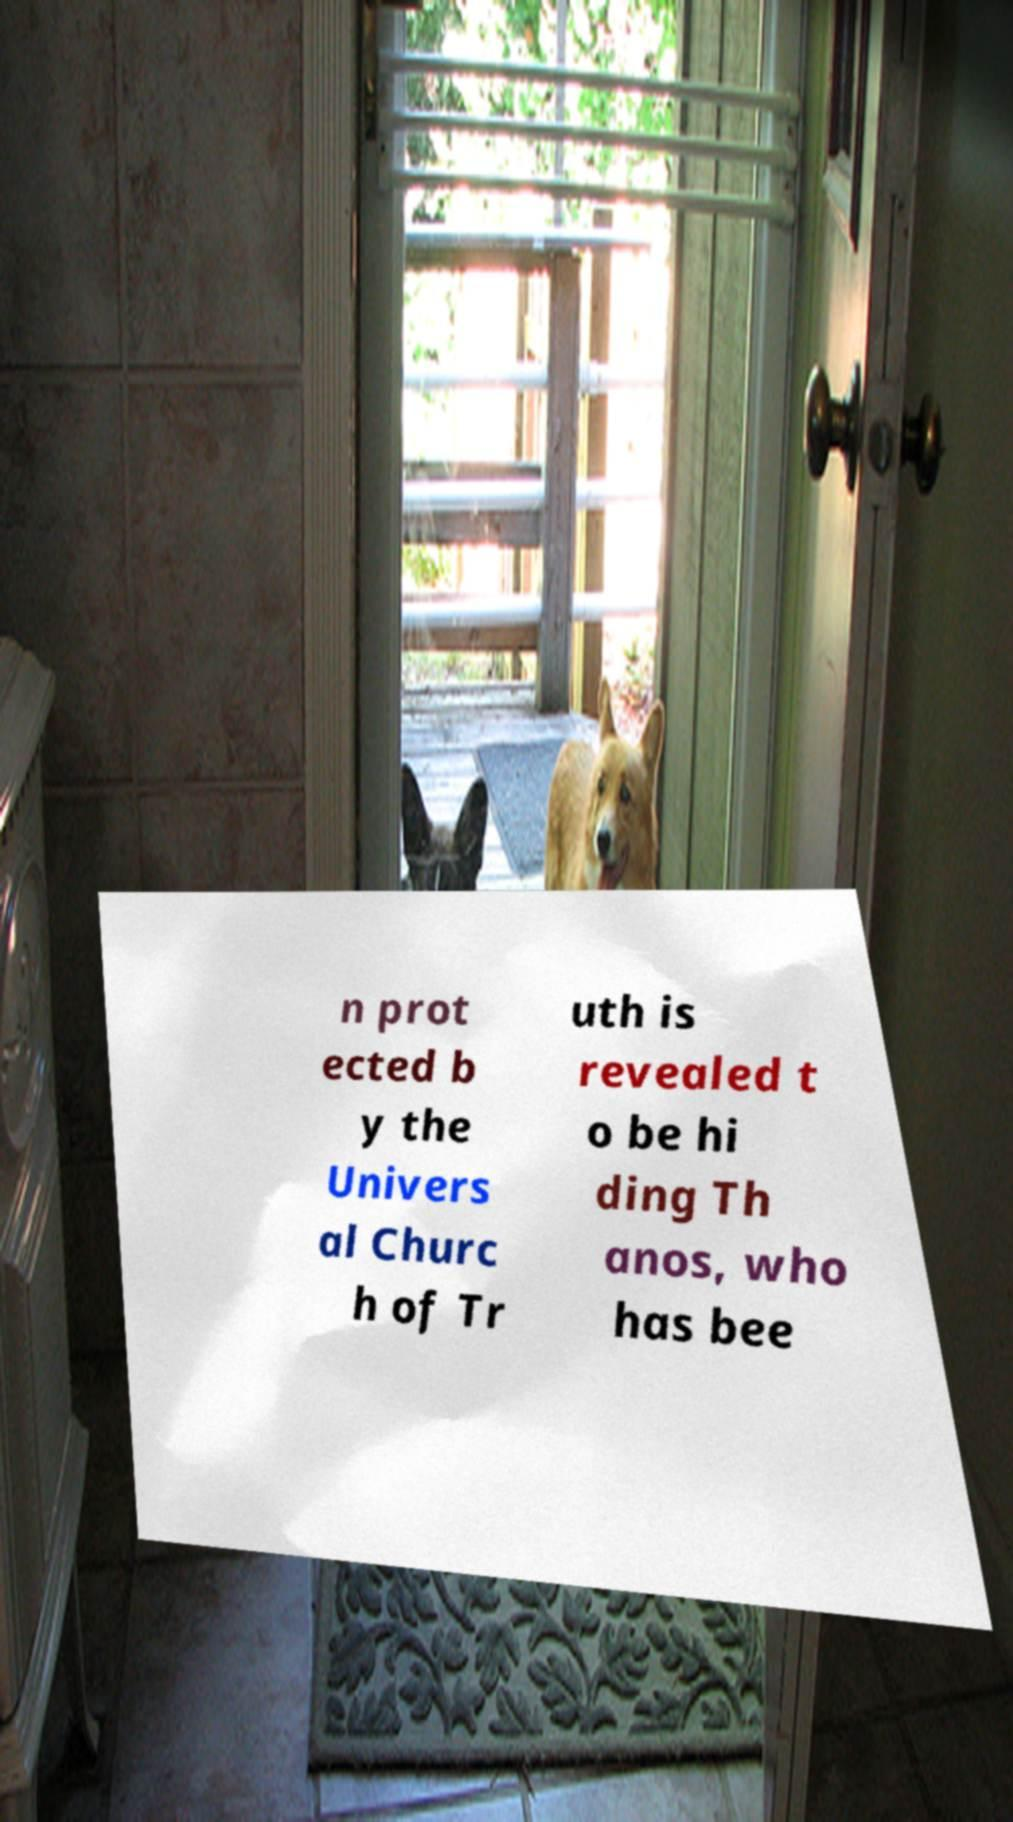For documentation purposes, I need the text within this image transcribed. Could you provide that? n prot ected b y the Univers al Churc h of Tr uth is revealed t o be hi ding Th anos, who has bee 